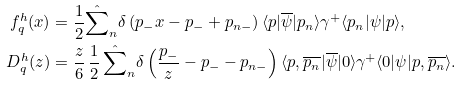Convert formula to latex. <formula><loc_0><loc_0><loc_500><loc_500>f _ { q } ^ { h } ( x ) & = \frac { 1 } { 2 } \hat { \sum } _ { n } \delta \left ( p _ { - } x - p _ { - } + p _ { n - } \right ) \langle p | \overline { \psi } | p _ { n } \rangle \gamma ^ { + } \langle p _ { n } | \psi | p \rangle , \\ D _ { q } ^ { h } ( z ) & = \frac { z } { 6 } \, \frac { 1 } { 2 } \, \hat { \sum } _ { n } \delta \left ( \frac { p _ { - } } { z } - p _ { - } - p _ { n - } \right ) \langle p , \overline { p _ { n } } | \overline { \psi } | 0 \rangle \gamma ^ { + } \langle 0 | \psi | p , \overline { p _ { n } } \rangle .</formula> 